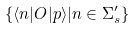<formula> <loc_0><loc_0><loc_500><loc_500>\{ \langle n | O | p \rangle | n \in \Sigma _ { s } ^ { \prime } \}</formula> 